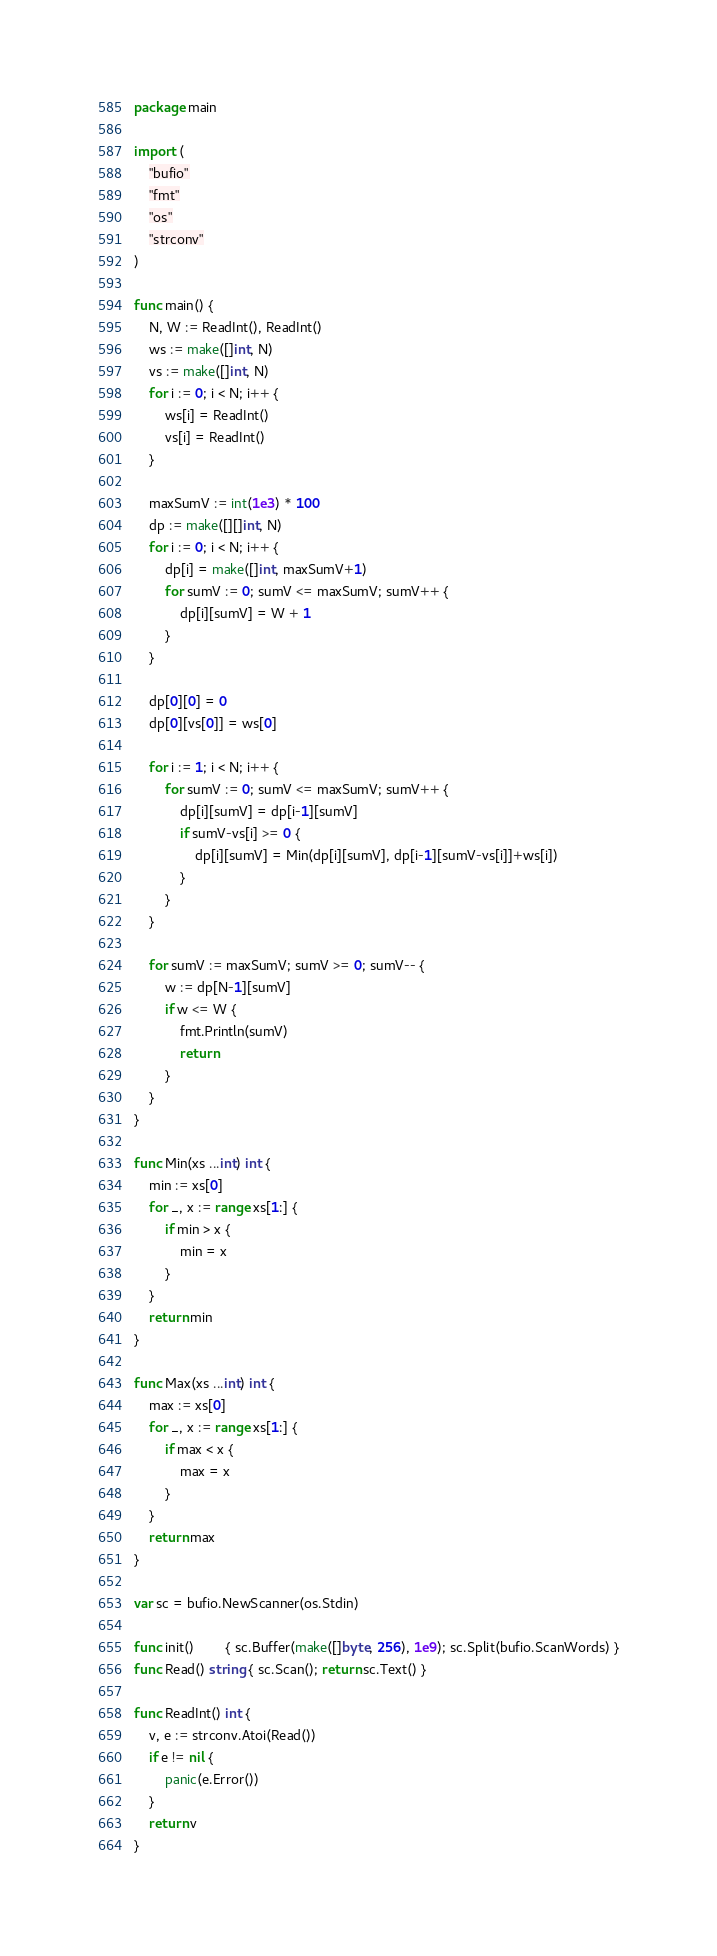<code> <loc_0><loc_0><loc_500><loc_500><_Go_>package main

import (
	"bufio"
	"fmt"
	"os"
	"strconv"
)

func main() {
	N, W := ReadInt(), ReadInt()
	ws := make([]int, N)
	vs := make([]int, N)
	for i := 0; i < N; i++ {
		ws[i] = ReadInt()
		vs[i] = ReadInt()
	}

	maxSumV := int(1e3) * 100
	dp := make([][]int, N)
	for i := 0; i < N; i++ {
		dp[i] = make([]int, maxSumV+1)
		for sumV := 0; sumV <= maxSumV; sumV++ {
			dp[i][sumV] = W + 1
		}
	}

	dp[0][0] = 0
	dp[0][vs[0]] = ws[0]

	for i := 1; i < N; i++ {
		for sumV := 0; sumV <= maxSumV; sumV++ {
			dp[i][sumV] = dp[i-1][sumV]
			if sumV-vs[i] >= 0 {
				dp[i][sumV] = Min(dp[i][sumV], dp[i-1][sumV-vs[i]]+ws[i])
			}
		}
	}

	for sumV := maxSumV; sumV >= 0; sumV-- {
		w := dp[N-1][sumV]
		if w <= W {
			fmt.Println(sumV)
			return
		}
	}
}

func Min(xs ...int) int {
	min := xs[0]
	for _, x := range xs[1:] {
		if min > x {
			min = x
		}
	}
	return min
}

func Max(xs ...int) int {
	max := xs[0]
	for _, x := range xs[1:] {
		if max < x {
			max = x
		}
	}
	return max
}

var sc = bufio.NewScanner(os.Stdin)

func init()        { sc.Buffer(make([]byte, 256), 1e9); sc.Split(bufio.ScanWords) }
func Read() string { sc.Scan(); return sc.Text() }

func ReadInt() int {
	v, e := strconv.Atoi(Read())
	if e != nil {
		panic(e.Error())
	}
	return v
}
</code> 